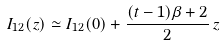<formula> <loc_0><loc_0><loc_500><loc_500>I _ { 1 2 } ( z ) \simeq I _ { 1 2 } ( 0 ) + \frac { ( t - 1 ) \beta + 2 } { 2 } \, z</formula> 